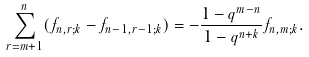<formula> <loc_0><loc_0><loc_500><loc_500>\sum _ { r = m + 1 } ^ { n } ( f _ { n , r ; k } - f _ { n - 1 , r - 1 ; k } ) = - \frac { 1 - q ^ { m - n } } { 1 - q ^ { n + k } } f _ { n , m ; k } .</formula> 